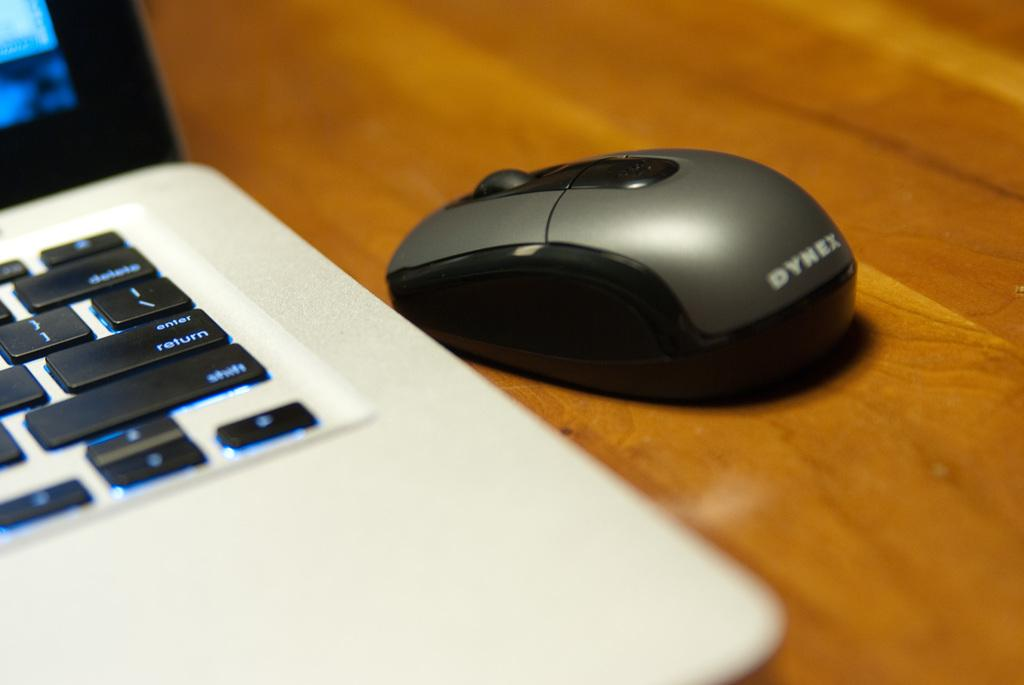Provide a one-sentence caption for the provided image. White and black laptop that includes a syrex wireless mouse. 